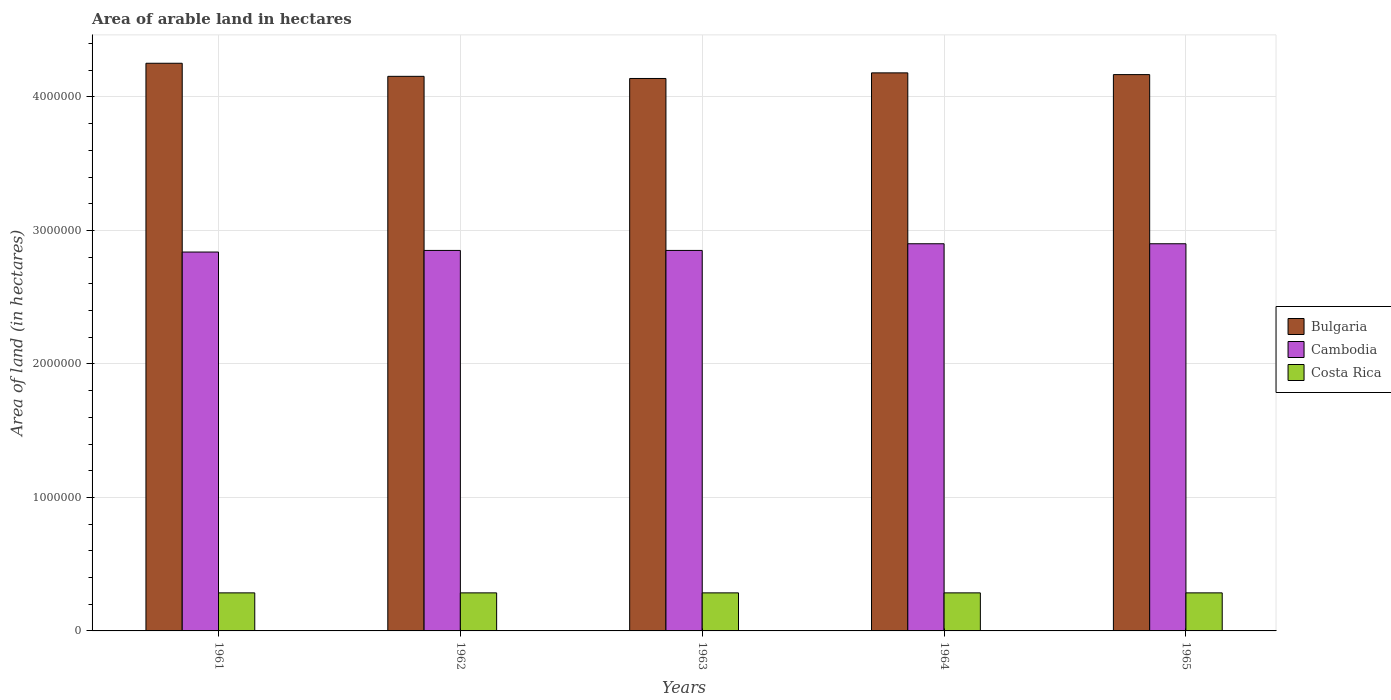How many bars are there on the 5th tick from the right?
Offer a very short reply. 3. What is the label of the 1st group of bars from the left?
Provide a short and direct response. 1961. What is the total arable land in Bulgaria in 1963?
Your answer should be very brief. 4.14e+06. Across all years, what is the maximum total arable land in Cambodia?
Provide a succinct answer. 2.90e+06. Across all years, what is the minimum total arable land in Cambodia?
Give a very brief answer. 2.84e+06. In which year was the total arable land in Bulgaria maximum?
Make the answer very short. 1961. What is the total total arable land in Costa Rica in the graph?
Your response must be concise. 1.42e+06. What is the difference between the total arable land in Cambodia in 1962 and that in 1965?
Ensure brevity in your answer.  -5.00e+04. What is the difference between the total arable land in Costa Rica in 1965 and the total arable land in Cambodia in 1963?
Make the answer very short. -2.56e+06. What is the average total arable land in Costa Rica per year?
Your answer should be very brief. 2.85e+05. In the year 1963, what is the difference between the total arable land in Bulgaria and total arable land in Cambodia?
Your answer should be compact. 1.29e+06. Is the total arable land in Cambodia in 1961 less than that in 1962?
Offer a terse response. Yes. What is the difference between the highest and the second highest total arable land in Costa Rica?
Offer a terse response. 0. What is the difference between the highest and the lowest total arable land in Costa Rica?
Keep it short and to the point. 0. What does the 2nd bar from the left in 1961 represents?
Provide a succinct answer. Cambodia. What does the 2nd bar from the right in 1961 represents?
Ensure brevity in your answer.  Cambodia. Is it the case that in every year, the sum of the total arable land in Costa Rica and total arable land in Cambodia is greater than the total arable land in Bulgaria?
Provide a short and direct response. No. Are all the bars in the graph horizontal?
Keep it short and to the point. No. What is the difference between two consecutive major ticks on the Y-axis?
Offer a terse response. 1.00e+06. Are the values on the major ticks of Y-axis written in scientific E-notation?
Ensure brevity in your answer.  No. Where does the legend appear in the graph?
Keep it short and to the point. Center right. How are the legend labels stacked?
Make the answer very short. Vertical. What is the title of the graph?
Give a very brief answer. Area of arable land in hectares. What is the label or title of the Y-axis?
Your answer should be compact. Area of land (in hectares). What is the Area of land (in hectares) in Bulgaria in 1961?
Your answer should be compact. 4.25e+06. What is the Area of land (in hectares) of Cambodia in 1961?
Ensure brevity in your answer.  2.84e+06. What is the Area of land (in hectares) in Costa Rica in 1961?
Provide a succinct answer. 2.85e+05. What is the Area of land (in hectares) in Bulgaria in 1962?
Ensure brevity in your answer.  4.15e+06. What is the Area of land (in hectares) of Cambodia in 1962?
Keep it short and to the point. 2.85e+06. What is the Area of land (in hectares) of Costa Rica in 1962?
Ensure brevity in your answer.  2.85e+05. What is the Area of land (in hectares) of Bulgaria in 1963?
Keep it short and to the point. 4.14e+06. What is the Area of land (in hectares) of Cambodia in 1963?
Provide a succinct answer. 2.85e+06. What is the Area of land (in hectares) in Costa Rica in 1963?
Provide a short and direct response. 2.85e+05. What is the Area of land (in hectares) in Bulgaria in 1964?
Offer a terse response. 4.18e+06. What is the Area of land (in hectares) in Cambodia in 1964?
Provide a succinct answer. 2.90e+06. What is the Area of land (in hectares) in Costa Rica in 1964?
Ensure brevity in your answer.  2.85e+05. What is the Area of land (in hectares) in Bulgaria in 1965?
Provide a short and direct response. 4.17e+06. What is the Area of land (in hectares) in Cambodia in 1965?
Provide a short and direct response. 2.90e+06. What is the Area of land (in hectares) in Costa Rica in 1965?
Provide a succinct answer. 2.85e+05. Across all years, what is the maximum Area of land (in hectares) of Bulgaria?
Ensure brevity in your answer.  4.25e+06. Across all years, what is the maximum Area of land (in hectares) in Cambodia?
Provide a succinct answer. 2.90e+06. Across all years, what is the maximum Area of land (in hectares) in Costa Rica?
Ensure brevity in your answer.  2.85e+05. Across all years, what is the minimum Area of land (in hectares) in Bulgaria?
Ensure brevity in your answer.  4.14e+06. Across all years, what is the minimum Area of land (in hectares) of Cambodia?
Give a very brief answer. 2.84e+06. Across all years, what is the minimum Area of land (in hectares) in Costa Rica?
Provide a short and direct response. 2.85e+05. What is the total Area of land (in hectares) of Bulgaria in the graph?
Ensure brevity in your answer.  2.09e+07. What is the total Area of land (in hectares) of Cambodia in the graph?
Keep it short and to the point. 1.43e+07. What is the total Area of land (in hectares) of Costa Rica in the graph?
Offer a very short reply. 1.42e+06. What is the difference between the Area of land (in hectares) of Bulgaria in 1961 and that in 1962?
Your response must be concise. 9.80e+04. What is the difference between the Area of land (in hectares) of Cambodia in 1961 and that in 1962?
Provide a succinct answer. -1.20e+04. What is the difference between the Area of land (in hectares) of Costa Rica in 1961 and that in 1962?
Make the answer very short. 0. What is the difference between the Area of land (in hectares) of Bulgaria in 1961 and that in 1963?
Keep it short and to the point. 1.14e+05. What is the difference between the Area of land (in hectares) of Cambodia in 1961 and that in 1963?
Your answer should be very brief. -1.20e+04. What is the difference between the Area of land (in hectares) of Bulgaria in 1961 and that in 1964?
Offer a very short reply. 7.20e+04. What is the difference between the Area of land (in hectares) in Cambodia in 1961 and that in 1964?
Your answer should be compact. -6.20e+04. What is the difference between the Area of land (in hectares) of Costa Rica in 1961 and that in 1964?
Make the answer very short. 0. What is the difference between the Area of land (in hectares) in Bulgaria in 1961 and that in 1965?
Ensure brevity in your answer.  8.50e+04. What is the difference between the Area of land (in hectares) in Cambodia in 1961 and that in 1965?
Give a very brief answer. -6.20e+04. What is the difference between the Area of land (in hectares) of Costa Rica in 1961 and that in 1965?
Your answer should be compact. 0. What is the difference between the Area of land (in hectares) of Bulgaria in 1962 and that in 1963?
Make the answer very short. 1.60e+04. What is the difference between the Area of land (in hectares) in Cambodia in 1962 and that in 1963?
Your answer should be very brief. 0. What is the difference between the Area of land (in hectares) of Bulgaria in 1962 and that in 1964?
Offer a terse response. -2.60e+04. What is the difference between the Area of land (in hectares) of Cambodia in 1962 and that in 1964?
Your answer should be compact. -5.00e+04. What is the difference between the Area of land (in hectares) of Costa Rica in 1962 and that in 1964?
Give a very brief answer. 0. What is the difference between the Area of land (in hectares) of Bulgaria in 1962 and that in 1965?
Provide a succinct answer. -1.30e+04. What is the difference between the Area of land (in hectares) of Costa Rica in 1962 and that in 1965?
Your response must be concise. 0. What is the difference between the Area of land (in hectares) in Bulgaria in 1963 and that in 1964?
Provide a succinct answer. -4.20e+04. What is the difference between the Area of land (in hectares) in Bulgaria in 1963 and that in 1965?
Provide a short and direct response. -2.90e+04. What is the difference between the Area of land (in hectares) of Bulgaria in 1964 and that in 1965?
Offer a terse response. 1.30e+04. What is the difference between the Area of land (in hectares) in Costa Rica in 1964 and that in 1965?
Your answer should be compact. 0. What is the difference between the Area of land (in hectares) of Bulgaria in 1961 and the Area of land (in hectares) of Cambodia in 1962?
Ensure brevity in your answer.  1.40e+06. What is the difference between the Area of land (in hectares) in Bulgaria in 1961 and the Area of land (in hectares) in Costa Rica in 1962?
Offer a very short reply. 3.97e+06. What is the difference between the Area of land (in hectares) in Cambodia in 1961 and the Area of land (in hectares) in Costa Rica in 1962?
Your response must be concise. 2.55e+06. What is the difference between the Area of land (in hectares) in Bulgaria in 1961 and the Area of land (in hectares) in Cambodia in 1963?
Provide a short and direct response. 1.40e+06. What is the difference between the Area of land (in hectares) of Bulgaria in 1961 and the Area of land (in hectares) of Costa Rica in 1963?
Keep it short and to the point. 3.97e+06. What is the difference between the Area of land (in hectares) in Cambodia in 1961 and the Area of land (in hectares) in Costa Rica in 1963?
Make the answer very short. 2.55e+06. What is the difference between the Area of land (in hectares) of Bulgaria in 1961 and the Area of land (in hectares) of Cambodia in 1964?
Give a very brief answer. 1.35e+06. What is the difference between the Area of land (in hectares) in Bulgaria in 1961 and the Area of land (in hectares) in Costa Rica in 1964?
Make the answer very short. 3.97e+06. What is the difference between the Area of land (in hectares) of Cambodia in 1961 and the Area of land (in hectares) of Costa Rica in 1964?
Offer a very short reply. 2.55e+06. What is the difference between the Area of land (in hectares) of Bulgaria in 1961 and the Area of land (in hectares) of Cambodia in 1965?
Make the answer very short. 1.35e+06. What is the difference between the Area of land (in hectares) of Bulgaria in 1961 and the Area of land (in hectares) of Costa Rica in 1965?
Provide a short and direct response. 3.97e+06. What is the difference between the Area of land (in hectares) in Cambodia in 1961 and the Area of land (in hectares) in Costa Rica in 1965?
Provide a succinct answer. 2.55e+06. What is the difference between the Area of land (in hectares) in Bulgaria in 1962 and the Area of land (in hectares) in Cambodia in 1963?
Offer a terse response. 1.30e+06. What is the difference between the Area of land (in hectares) of Bulgaria in 1962 and the Area of land (in hectares) of Costa Rica in 1963?
Provide a short and direct response. 3.87e+06. What is the difference between the Area of land (in hectares) in Cambodia in 1962 and the Area of land (in hectares) in Costa Rica in 1963?
Make the answer very short. 2.56e+06. What is the difference between the Area of land (in hectares) of Bulgaria in 1962 and the Area of land (in hectares) of Cambodia in 1964?
Your response must be concise. 1.25e+06. What is the difference between the Area of land (in hectares) of Bulgaria in 1962 and the Area of land (in hectares) of Costa Rica in 1964?
Give a very brief answer. 3.87e+06. What is the difference between the Area of land (in hectares) of Cambodia in 1962 and the Area of land (in hectares) of Costa Rica in 1964?
Ensure brevity in your answer.  2.56e+06. What is the difference between the Area of land (in hectares) in Bulgaria in 1962 and the Area of land (in hectares) in Cambodia in 1965?
Offer a terse response. 1.25e+06. What is the difference between the Area of land (in hectares) in Bulgaria in 1962 and the Area of land (in hectares) in Costa Rica in 1965?
Offer a terse response. 3.87e+06. What is the difference between the Area of land (in hectares) in Cambodia in 1962 and the Area of land (in hectares) in Costa Rica in 1965?
Your answer should be compact. 2.56e+06. What is the difference between the Area of land (in hectares) in Bulgaria in 1963 and the Area of land (in hectares) in Cambodia in 1964?
Make the answer very short. 1.24e+06. What is the difference between the Area of land (in hectares) in Bulgaria in 1963 and the Area of land (in hectares) in Costa Rica in 1964?
Your answer should be compact. 3.85e+06. What is the difference between the Area of land (in hectares) of Cambodia in 1963 and the Area of land (in hectares) of Costa Rica in 1964?
Provide a short and direct response. 2.56e+06. What is the difference between the Area of land (in hectares) of Bulgaria in 1963 and the Area of land (in hectares) of Cambodia in 1965?
Provide a succinct answer. 1.24e+06. What is the difference between the Area of land (in hectares) in Bulgaria in 1963 and the Area of land (in hectares) in Costa Rica in 1965?
Offer a very short reply. 3.85e+06. What is the difference between the Area of land (in hectares) in Cambodia in 1963 and the Area of land (in hectares) in Costa Rica in 1965?
Provide a short and direct response. 2.56e+06. What is the difference between the Area of land (in hectares) in Bulgaria in 1964 and the Area of land (in hectares) in Cambodia in 1965?
Keep it short and to the point. 1.28e+06. What is the difference between the Area of land (in hectares) of Bulgaria in 1964 and the Area of land (in hectares) of Costa Rica in 1965?
Offer a terse response. 3.90e+06. What is the difference between the Area of land (in hectares) of Cambodia in 1964 and the Area of land (in hectares) of Costa Rica in 1965?
Provide a succinct answer. 2.62e+06. What is the average Area of land (in hectares) in Bulgaria per year?
Offer a very short reply. 4.18e+06. What is the average Area of land (in hectares) in Cambodia per year?
Offer a terse response. 2.87e+06. What is the average Area of land (in hectares) in Costa Rica per year?
Your response must be concise. 2.85e+05. In the year 1961, what is the difference between the Area of land (in hectares) of Bulgaria and Area of land (in hectares) of Cambodia?
Offer a terse response. 1.41e+06. In the year 1961, what is the difference between the Area of land (in hectares) of Bulgaria and Area of land (in hectares) of Costa Rica?
Offer a very short reply. 3.97e+06. In the year 1961, what is the difference between the Area of land (in hectares) in Cambodia and Area of land (in hectares) in Costa Rica?
Offer a very short reply. 2.55e+06. In the year 1962, what is the difference between the Area of land (in hectares) of Bulgaria and Area of land (in hectares) of Cambodia?
Provide a succinct answer. 1.30e+06. In the year 1962, what is the difference between the Area of land (in hectares) in Bulgaria and Area of land (in hectares) in Costa Rica?
Give a very brief answer. 3.87e+06. In the year 1962, what is the difference between the Area of land (in hectares) in Cambodia and Area of land (in hectares) in Costa Rica?
Provide a short and direct response. 2.56e+06. In the year 1963, what is the difference between the Area of land (in hectares) in Bulgaria and Area of land (in hectares) in Cambodia?
Ensure brevity in your answer.  1.29e+06. In the year 1963, what is the difference between the Area of land (in hectares) of Bulgaria and Area of land (in hectares) of Costa Rica?
Your answer should be compact. 3.85e+06. In the year 1963, what is the difference between the Area of land (in hectares) of Cambodia and Area of land (in hectares) of Costa Rica?
Your response must be concise. 2.56e+06. In the year 1964, what is the difference between the Area of land (in hectares) in Bulgaria and Area of land (in hectares) in Cambodia?
Offer a very short reply. 1.28e+06. In the year 1964, what is the difference between the Area of land (in hectares) of Bulgaria and Area of land (in hectares) of Costa Rica?
Give a very brief answer. 3.90e+06. In the year 1964, what is the difference between the Area of land (in hectares) in Cambodia and Area of land (in hectares) in Costa Rica?
Give a very brief answer. 2.62e+06. In the year 1965, what is the difference between the Area of land (in hectares) in Bulgaria and Area of land (in hectares) in Cambodia?
Provide a short and direct response. 1.27e+06. In the year 1965, what is the difference between the Area of land (in hectares) in Bulgaria and Area of land (in hectares) in Costa Rica?
Your answer should be very brief. 3.88e+06. In the year 1965, what is the difference between the Area of land (in hectares) in Cambodia and Area of land (in hectares) in Costa Rica?
Your answer should be very brief. 2.62e+06. What is the ratio of the Area of land (in hectares) of Bulgaria in 1961 to that in 1962?
Provide a short and direct response. 1.02. What is the ratio of the Area of land (in hectares) in Cambodia in 1961 to that in 1962?
Keep it short and to the point. 1. What is the ratio of the Area of land (in hectares) of Costa Rica in 1961 to that in 1962?
Provide a short and direct response. 1. What is the ratio of the Area of land (in hectares) in Bulgaria in 1961 to that in 1963?
Offer a terse response. 1.03. What is the ratio of the Area of land (in hectares) of Cambodia in 1961 to that in 1963?
Give a very brief answer. 1. What is the ratio of the Area of land (in hectares) in Bulgaria in 1961 to that in 1964?
Offer a very short reply. 1.02. What is the ratio of the Area of land (in hectares) of Cambodia in 1961 to that in 1964?
Your response must be concise. 0.98. What is the ratio of the Area of land (in hectares) of Costa Rica in 1961 to that in 1964?
Your answer should be very brief. 1. What is the ratio of the Area of land (in hectares) in Bulgaria in 1961 to that in 1965?
Ensure brevity in your answer.  1.02. What is the ratio of the Area of land (in hectares) in Cambodia in 1961 to that in 1965?
Provide a short and direct response. 0.98. What is the ratio of the Area of land (in hectares) of Cambodia in 1962 to that in 1963?
Make the answer very short. 1. What is the ratio of the Area of land (in hectares) in Cambodia in 1962 to that in 1964?
Provide a succinct answer. 0.98. What is the ratio of the Area of land (in hectares) in Bulgaria in 1962 to that in 1965?
Ensure brevity in your answer.  1. What is the ratio of the Area of land (in hectares) in Cambodia in 1962 to that in 1965?
Your answer should be very brief. 0.98. What is the ratio of the Area of land (in hectares) in Cambodia in 1963 to that in 1964?
Your answer should be compact. 0.98. What is the ratio of the Area of land (in hectares) in Costa Rica in 1963 to that in 1964?
Keep it short and to the point. 1. What is the ratio of the Area of land (in hectares) in Cambodia in 1963 to that in 1965?
Offer a very short reply. 0.98. What is the ratio of the Area of land (in hectares) of Costa Rica in 1963 to that in 1965?
Your answer should be very brief. 1. What is the ratio of the Area of land (in hectares) of Bulgaria in 1964 to that in 1965?
Offer a terse response. 1. What is the ratio of the Area of land (in hectares) in Cambodia in 1964 to that in 1965?
Ensure brevity in your answer.  1. What is the difference between the highest and the second highest Area of land (in hectares) of Bulgaria?
Make the answer very short. 7.20e+04. What is the difference between the highest and the second highest Area of land (in hectares) in Costa Rica?
Your answer should be very brief. 0. What is the difference between the highest and the lowest Area of land (in hectares) in Bulgaria?
Your answer should be very brief. 1.14e+05. What is the difference between the highest and the lowest Area of land (in hectares) of Cambodia?
Provide a short and direct response. 6.20e+04. 